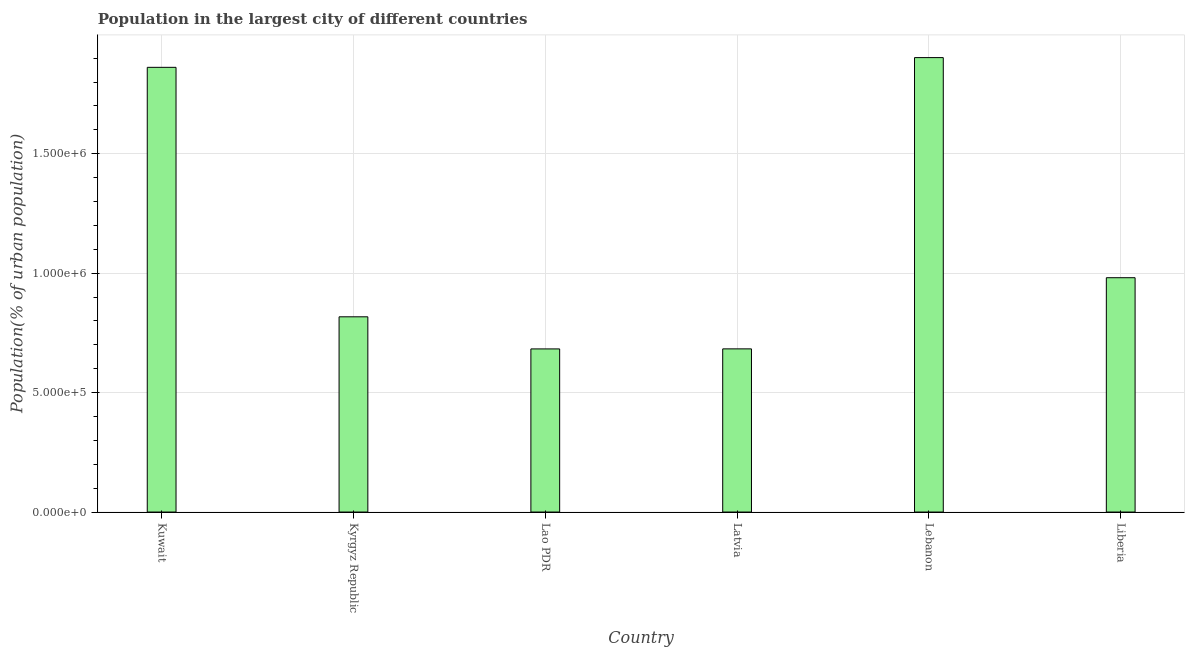Does the graph contain grids?
Offer a terse response. Yes. What is the title of the graph?
Offer a very short reply. Population in the largest city of different countries. What is the label or title of the X-axis?
Offer a very short reply. Country. What is the label or title of the Y-axis?
Provide a succinct answer. Population(% of urban population). What is the population in largest city in Lao PDR?
Make the answer very short. 6.83e+05. Across all countries, what is the maximum population in largest city?
Your answer should be very brief. 1.90e+06. Across all countries, what is the minimum population in largest city?
Your answer should be compact. 6.83e+05. In which country was the population in largest city maximum?
Make the answer very short. Lebanon. In which country was the population in largest city minimum?
Offer a very short reply. Lao PDR. What is the sum of the population in largest city?
Offer a terse response. 6.93e+06. What is the difference between the population in largest city in Lao PDR and Lebanon?
Provide a succinct answer. -1.22e+06. What is the average population in largest city per country?
Offer a very short reply. 1.15e+06. What is the median population in largest city?
Your answer should be very brief. 8.99e+05. In how many countries, is the population in largest city greater than 1500000 %?
Make the answer very short. 2. Is the population in largest city in Latvia less than that in Liberia?
Keep it short and to the point. Yes. Is the difference between the population in largest city in Kyrgyz Republic and Latvia greater than the difference between any two countries?
Make the answer very short. No. What is the difference between the highest and the second highest population in largest city?
Offer a terse response. 4.08e+04. Is the sum of the population in largest city in Lebanon and Liberia greater than the maximum population in largest city across all countries?
Give a very brief answer. Yes. What is the difference between the highest and the lowest population in largest city?
Make the answer very short. 1.22e+06. In how many countries, is the population in largest city greater than the average population in largest city taken over all countries?
Give a very brief answer. 2. What is the difference between two consecutive major ticks on the Y-axis?
Your response must be concise. 5.00e+05. What is the Population(% of urban population) in Kuwait?
Keep it short and to the point. 1.86e+06. What is the Population(% of urban population) in Kyrgyz Republic?
Your response must be concise. 8.17e+05. What is the Population(% of urban population) in Lao PDR?
Keep it short and to the point. 6.83e+05. What is the Population(% of urban population) in Latvia?
Your answer should be compact. 6.83e+05. What is the Population(% of urban population) in Lebanon?
Make the answer very short. 1.90e+06. What is the Population(% of urban population) in Liberia?
Ensure brevity in your answer.  9.81e+05. What is the difference between the Population(% of urban population) in Kuwait and Kyrgyz Republic?
Make the answer very short. 1.04e+06. What is the difference between the Population(% of urban population) in Kuwait and Lao PDR?
Your answer should be compact. 1.18e+06. What is the difference between the Population(% of urban population) in Kuwait and Latvia?
Ensure brevity in your answer.  1.18e+06. What is the difference between the Population(% of urban population) in Kuwait and Lebanon?
Your answer should be very brief. -4.08e+04. What is the difference between the Population(% of urban population) in Kuwait and Liberia?
Your response must be concise. 8.81e+05. What is the difference between the Population(% of urban population) in Kyrgyz Republic and Lao PDR?
Provide a succinct answer. 1.34e+05. What is the difference between the Population(% of urban population) in Kyrgyz Republic and Latvia?
Your answer should be very brief. 1.34e+05. What is the difference between the Population(% of urban population) in Kyrgyz Republic and Lebanon?
Make the answer very short. -1.09e+06. What is the difference between the Population(% of urban population) in Kyrgyz Republic and Liberia?
Offer a terse response. -1.64e+05. What is the difference between the Population(% of urban population) in Lao PDR and Latvia?
Provide a short and direct response. -205. What is the difference between the Population(% of urban population) in Lao PDR and Lebanon?
Your response must be concise. -1.22e+06. What is the difference between the Population(% of urban population) in Lao PDR and Liberia?
Provide a short and direct response. -2.98e+05. What is the difference between the Population(% of urban population) in Latvia and Lebanon?
Make the answer very short. -1.22e+06. What is the difference between the Population(% of urban population) in Latvia and Liberia?
Your answer should be very brief. -2.98e+05. What is the difference between the Population(% of urban population) in Lebanon and Liberia?
Provide a short and direct response. 9.21e+05. What is the ratio of the Population(% of urban population) in Kuwait to that in Kyrgyz Republic?
Offer a very short reply. 2.28. What is the ratio of the Population(% of urban population) in Kuwait to that in Lao PDR?
Keep it short and to the point. 2.73. What is the ratio of the Population(% of urban population) in Kuwait to that in Latvia?
Make the answer very short. 2.73. What is the ratio of the Population(% of urban population) in Kuwait to that in Liberia?
Provide a succinct answer. 1.9. What is the ratio of the Population(% of urban population) in Kyrgyz Republic to that in Lao PDR?
Your answer should be compact. 1.2. What is the ratio of the Population(% of urban population) in Kyrgyz Republic to that in Latvia?
Make the answer very short. 1.2. What is the ratio of the Population(% of urban population) in Kyrgyz Republic to that in Lebanon?
Offer a terse response. 0.43. What is the ratio of the Population(% of urban population) in Kyrgyz Republic to that in Liberia?
Offer a terse response. 0.83. What is the ratio of the Population(% of urban population) in Lao PDR to that in Lebanon?
Give a very brief answer. 0.36. What is the ratio of the Population(% of urban population) in Lao PDR to that in Liberia?
Offer a terse response. 0.7. What is the ratio of the Population(% of urban population) in Latvia to that in Lebanon?
Your answer should be compact. 0.36. What is the ratio of the Population(% of urban population) in Latvia to that in Liberia?
Your answer should be compact. 0.7. What is the ratio of the Population(% of urban population) in Lebanon to that in Liberia?
Make the answer very short. 1.94. 